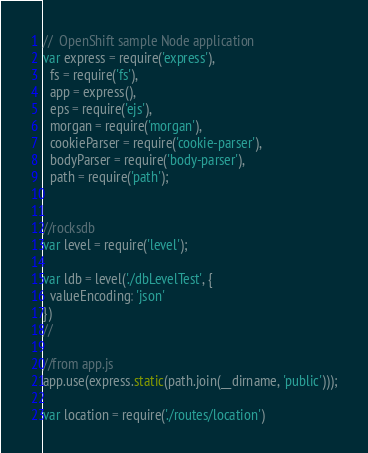Convert code to text. <code><loc_0><loc_0><loc_500><loc_500><_JavaScript_>//  OpenShift sample Node application
var express = require('express'),
  fs = require('fs'),
  app = express(),
  eps = require('ejs'),
  morgan = require('morgan'),
  cookieParser = require('cookie-parser'),
  bodyParser = require('body-parser'),
  path = require('path');


//rocksdb
var level = require('level');

var ldb = level('./dbLevelTest', {
  valueEncoding: 'json'
})
//

//from app.js
app.use(express.static(path.join(__dirname, 'public')));

var location = require('./routes/location')</code> 